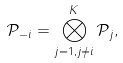Convert formula to latex. <formula><loc_0><loc_0><loc_500><loc_500>\mathcal { P } _ { - i } = \bigotimes _ { j = 1 , j \neq i } ^ { K } \mathcal { P } _ { j } ,</formula> 